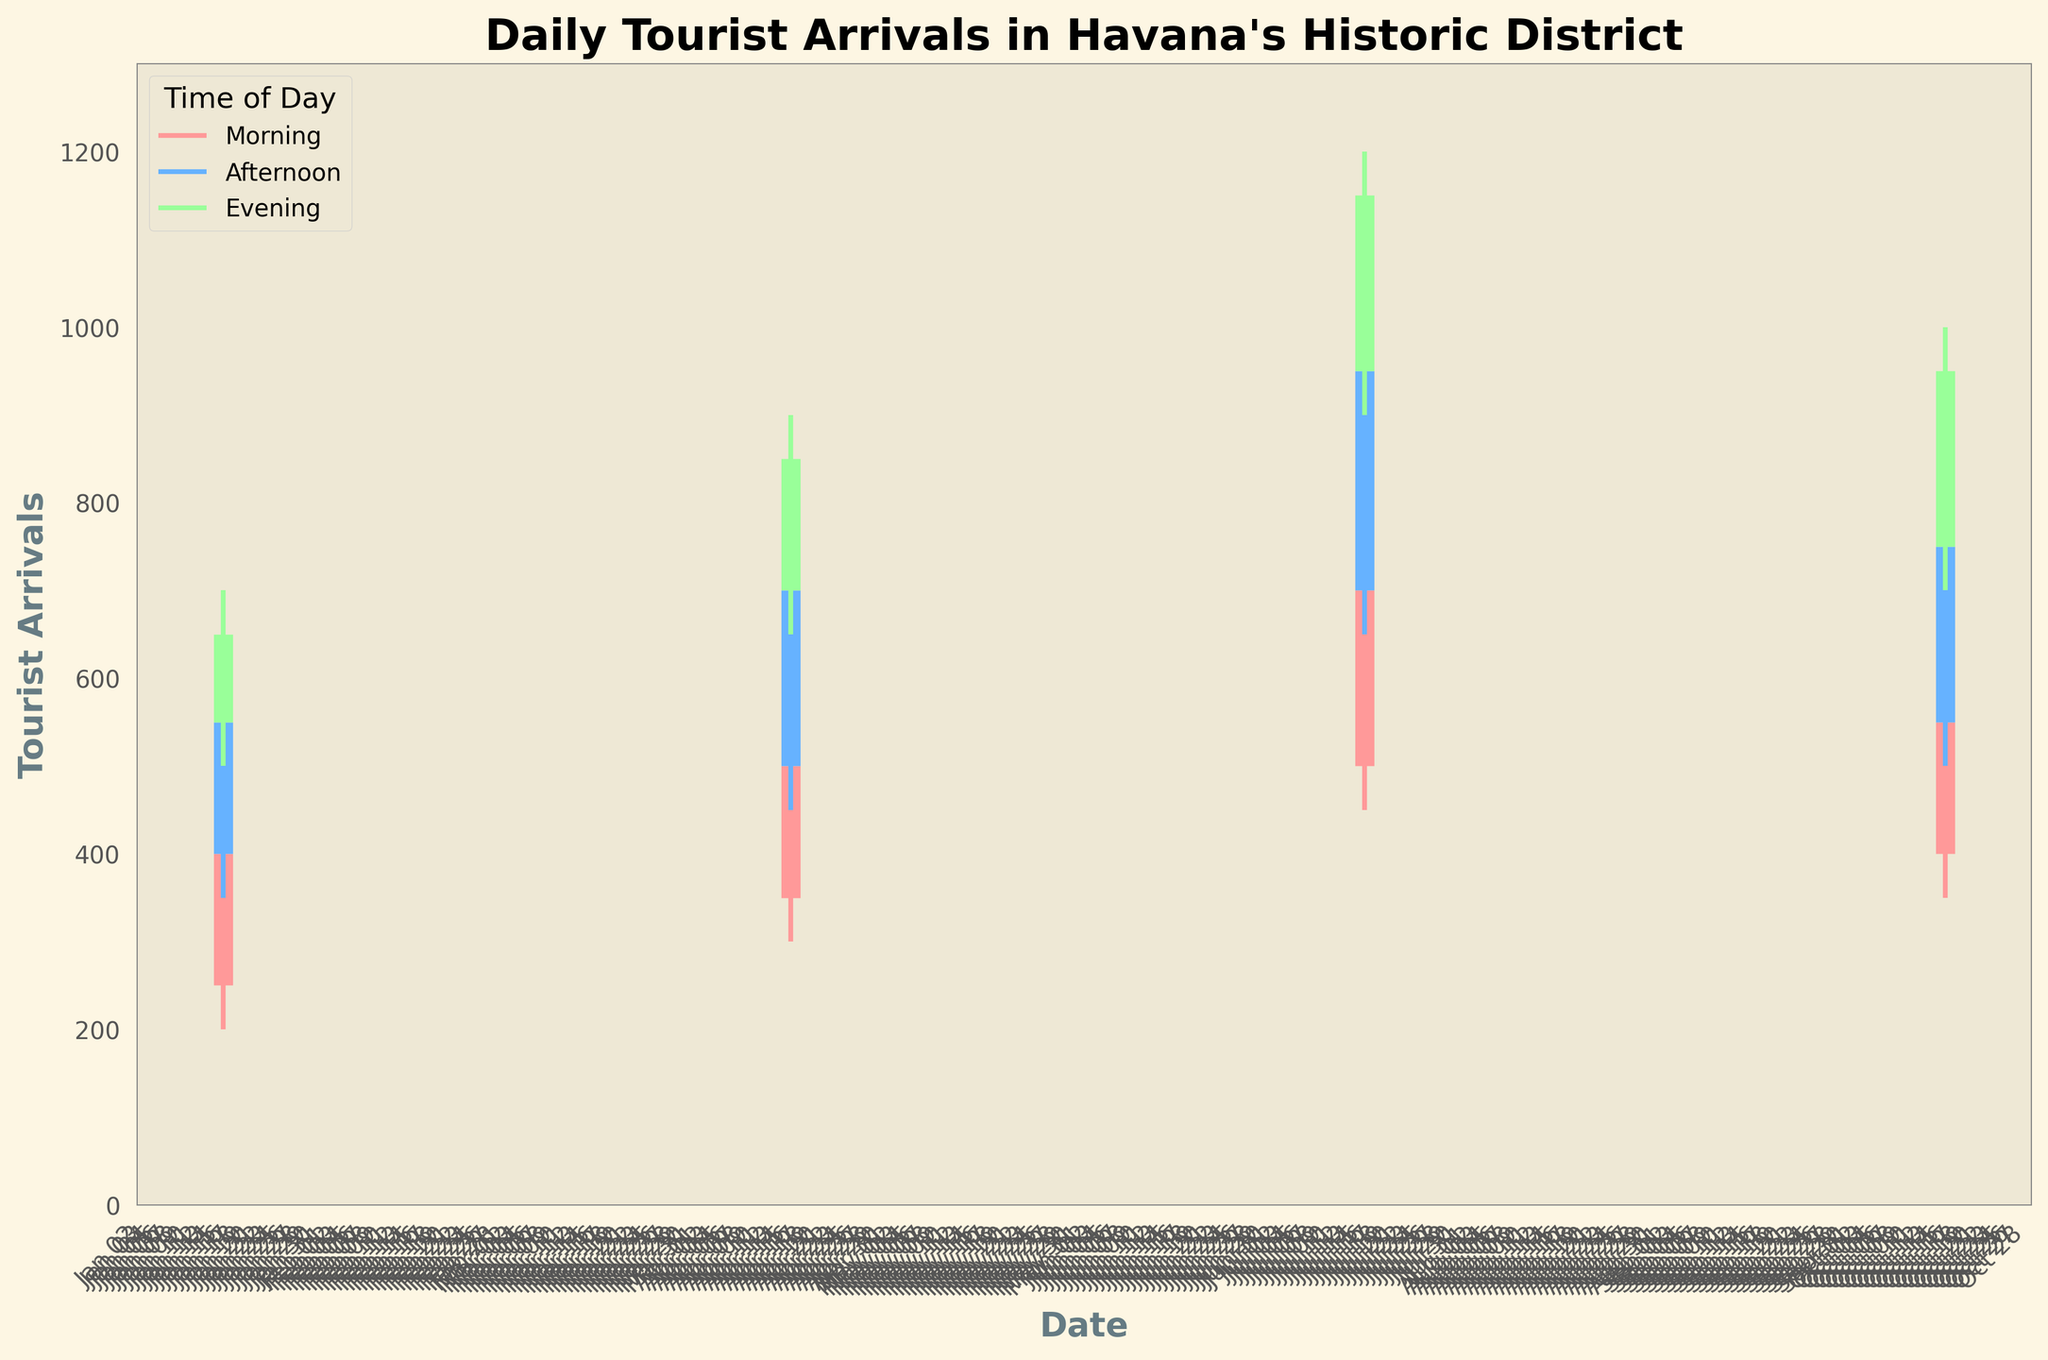What is the title of the chart? The title is written at the top of the chart and provides a high-level description of what the chart represents.
Answer: Daily Tourist Arrivals in Havana's Historic District What time of day is represented by the green color in the chart? The chart uses color to differentiate between times of day. By looking at the legend, we can see which color corresponds to which time of day.
Answer: Evening What is the range of tourist arrivals in the Winter Morning on January 15, 2023? The range is the difference between the highest and lowest values. For Winter Morning on January 15, 2023, the high is 450 and the low is 200, so the range is 450 - 200.
Answer: 250 Which season shows the highest tourist arrivals in the Evening and what is the value? To find this, we need to look at the Evening bar for each season and compare the values. The highest value will indicate the season with the most tourist arrivals in the Evening.
Answer: Summer, 1200 What is the average number of tourist arrivals in the Afternoon during Spring? To find the average, add the Open (500) and Close (700) values and divide by 2. (500 + 700) / 2 = 600.
Answer: 600 How does tourist arrival in Summer Evening compare to Spring Evening? Compare the Close values for Summer Evening and Spring Evening. Summer Evening is 1150 and Spring Evening is 900.
Answer: Summer Evening is higher by 250 Which time of day in Fall has the lowest range of tourist arrivals and what is the value? Calculate the range for each time of day in Fall (Morning: 600-350, Afternoon: 800-500, Evening: 1000-700). The smallest difference is Fall Morning.
Answer: Morning, 250 What trend can be observed in tourist arrivals from Winter to Fall for Mornings? By looking at the chart's Morning bars from Winter to Fall, one can see whether the tourist arrivals increase, decrease, or remain constant.
Answer: Increasing What is the difference in the high value of tourist arrivals between Spring Afternoon and Summer Afternoon? Subtract the high value of Spring Afternoon (750) from Summer Afternoon (1000). 1000 - 750 = 250.
Answer: 250 How do the tourist arrival patterns differ between Winter and Summer? Compare the range and Close values for each time of day in Winter and Summer. Winter has lower overall values compared to Summer, indicating fewer tourist arrivals.
Answer: Summer has higher arrivals across all times of day 